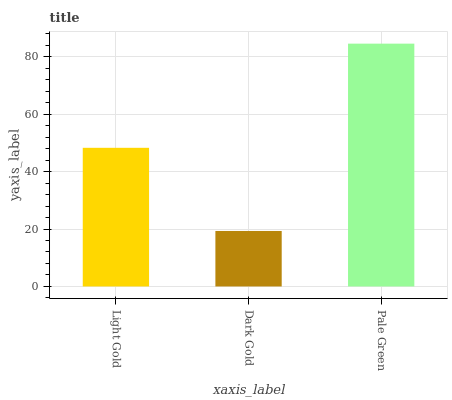Is Pale Green the minimum?
Answer yes or no. No. Is Dark Gold the maximum?
Answer yes or no. No. Is Pale Green greater than Dark Gold?
Answer yes or no. Yes. Is Dark Gold less than Pale Green?
Answer yes or no. Yes. Is Dark Gold greater than Pale Green?
Answer yes or no. No. Is Pale Green less than Dark Gold?
Answer yes or no. No. Is Light Gold the high median?
Answer yes or no. Yes. Is Light Gold the low median?
Answer yes or no. Yes. Is Dark Gold the high median?
Answer yes or no. No. Is Pale Green the low median?
Answer yes or no. No. 